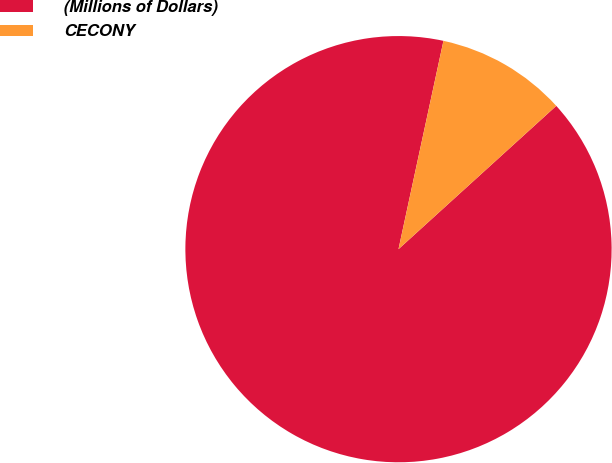<chart> <loc_0><loc_0><loc_500><loc_500><pie_chart><fcel>(Millions of Dollars)<fcel>CECONY<nl><fcel>90.12%<fcel>9.88%<nl></chart> 